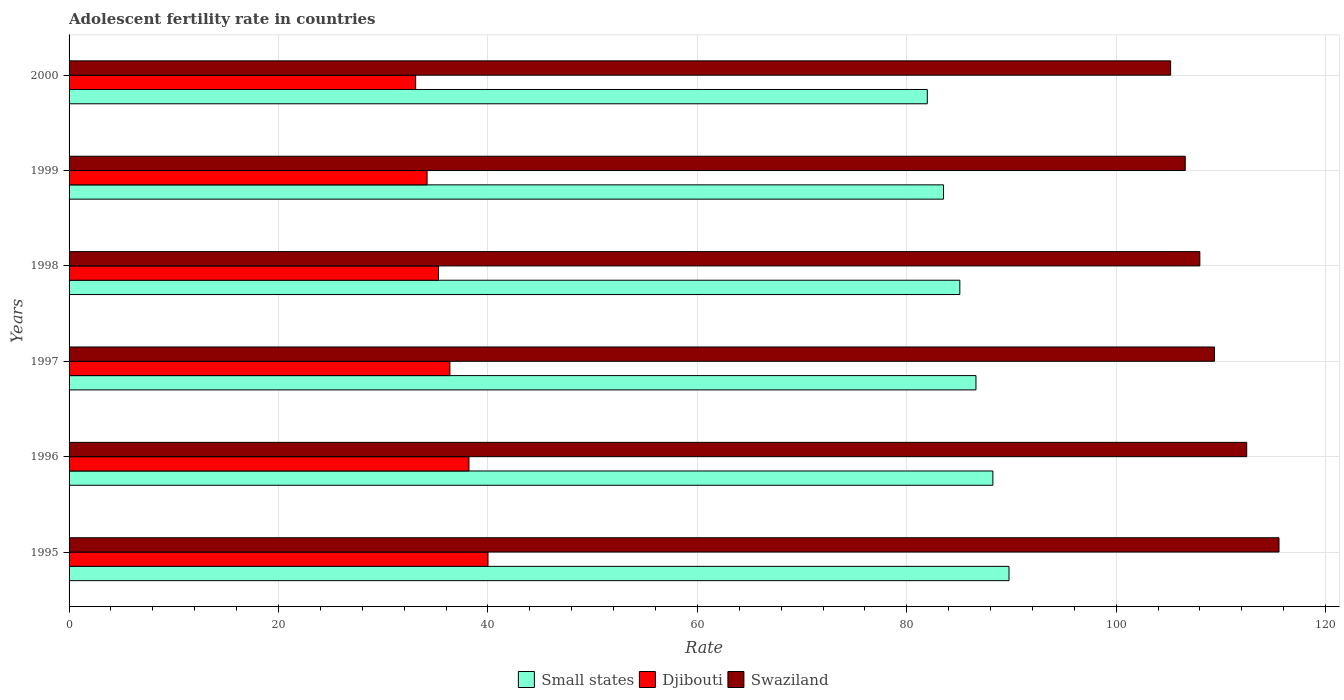Are the number of bars on each tick of the Y-axis equal?
Ensure brevity in your answer.  Yes. How many bars are there on the 3rd tick from the top?
Keep it short and to the point. 3. In how many cases, is the number of bars for a given year not equal to the number of legend labels?
Keep it short and to the point. 0. What is the adolescent fertility rate in Swaziland in 1998?
Your response must be concise. 107.99. Across all years, what is the maximum adolescent fertility rate in Small states?
Provide a short and direct response. 89.76. Across all years, what is the minimum adolescent fertility rate in Swaziland?
Provide a short and direct response. 105.2. In which year was the adolescent fertility rate in Djibouti maximum?
Your answer should be compact. 1995. What is the total adolescent fertility rate in Djibouti in the graph?
Give a very brief answer. 217.13. What is the difference between the adolescent fertility rate in Swaziland in 1997 and that in 1999?
Ensure brevity in your answer.  2.79. What is the difference between the adolescent fertility rate in Swaziland in 1998 and the adolescent fertility rate in Djibouti in 1997?
Provide a succinct answer. 71.62. What is the average adolescent fertility rate in Swaziland per year?
Provide a short and direct response. 109.53. In the year 2000, what is the difference between the adolescent fertility rate in Djibouti and adolescent fertility rate in Small states?
Keep it short and to the point. -48.86. What is the ratio of the adolescent fertility rate in Djibouti in 1998 to that in 1999?
Your answer should be very brief. 1.03. What is the difference between the highest and the second highest adolescent fertility rate in Swaziland?
Your answer should be very brief. 3.08. What is the difference between the highest and the lowest adolescent fertility rate in Swaziland?
Offer a terse response. 10.35. In how many years, is the adolescent fertility rate in Small states greater than the average adolescent fertility rate in Small states taken over all years?
Offer a very short reply. 3. Is the sum of the adolescent fertility rate in Djibouti in 1998 and 2000 greater than the maximum adolescent fertility rate in Small states across all years?
Offer a terse response. No. What does the 2nd bar from the top in 2000 represents?
Offer a terse response. Djibouti. What does the 3rd bar from the bottom in 1997 represents?
Offer a very short reply. Swaziland. Are all the bars in the graph horizontal?
Your answer should be very brief. Yes. How many years are there in the graph?
Offer a terse response. 6. What is the difference between two consecutive major ticks on the X-axis?
Your response must be concise. 20. Are the values on the major ticks of X-axis written in scientific E-notation?
Ensure brevity in your answer.  No. Does the graph contain any zero values?
Your answer should be very brief. No. What is the title of the graph?
Make the answer very short. Adolescent fertility rate in countries. What is the label or title of the X-axis?
Offer a terse response. Rate. What is the Rate of Small states in 1995?
Provide a short and direct response. 89.76. What is the Rate in Djibouti in 1995?
Your answer should be compact. 40.01. What is the Rate of Swaziland in 1995?
Your answer should be very brief. 115.55. What is the Rate of Small states in 1996?
Your answer should be very brief. 88.22. What is the Rate of Djibouti in 1996?
Your answer should be very brief. 38.19. What is the Rate of Swaziland in 1996?
Ensure brevity in your answer.  112.47. What is the Rate in Small states in 1997?
Your response must be concise. 86.61. What is the Rate in Djibouti in 1997?
Your answer should be compact. 36.37. What is the Rate of Swaziland in 1997?
Provide a short and direct response. 109.38. What is the Rate in Small states in 1998?
Make the answer very short. 85.07. What is the Rate in Djibouti in 1998?
Offer a very short reply. 35.28. What is the Rate of Swaziland in 1998?
Your answer should be very brief. 107.99. What is the Rate in Small states in 1999?
Make the answer very short. 83.51. What is the Rate of Djibouti in 1999?
Ensure brevity in your answer.  34.19. What is the Rate of Swaziland in 1999?
Your answer should be very brief. 106.59. What is the Rate of Small states in 2000?
Your answer should be very brief. 81.96. What is the Rate in Djibouti in 2000?
Ensure brevity in your answer.  33.1. What is the Rate in Swaziland in 2000?
Your answer should be compact. 105.2. Across all years, what is the maximum Rate of Small states?
Offer a terse response. 89.76. Across all years, what is the maximum Rate of Djibouti?
Give a very brief answer. 40.01. Across all years, what is the maximum Rate of Swaziland?
Your response must be concise. 115.55. Across all years, what is the minimum Rate in Small states?
Your response must be concise. 81.96. Across all years, what is the minimum Rate of Djibouti?
Provide a short and direct response. 33.1. Across all years, what is the minimum Rate of Swaziland?
Provide a succinct answer. 105.2. What is the total Rate in Small states in the graph?
Make the answer very short. 515.13. What is the total Rate of Djibouti in the graph?
Ensure brevity in your answer.  217.13. What is the total Rate of Swaziland in the graph?
Offer a terse response. 657.17. What is the difference between the Rate in Small states in 1995 and that in 1996?
Your answer should be very brief. 1.54. What is the difference between the Rate in Djibouti in 1995 and that in 1996?
Offer a very short reply. 1.82. What is the difference between the Rate of Swaziland in 1995 and that in 1996?
Offer a very short reply. 3.08. What is the difference between the Rate in Small states in 1995 and that in 1997?
Provide a short and direct response. 3.16. What is the difference between the Rate in Djibouti in 1995 and that in 1997?
Provide a short and direct response. 3.64. What is the difference between the Rate of Swaziland in 1995 and that in 1997?
Ensure brevity in your answer.  6.16. What is the difference between the Rate of Small states in 1995 and that in 1998?
Your response must be concise. 4.7. What is the difference between the Rate of Djibouti in 1995 and that in 1998?
Your response must be concise. 4.73. What is the difference between the Rate of Swaziland in 1995 and that in 1998?
Offer a very short reply. 7.56. What is the difference between the Rate of Small states in 1995 and that in 1999?
Provide a short and direct response. 6.25. What is the difference between the Rate of Djibouti in 1995 and that in 1999?
Keep it short and to the point. 5.82. What is the difference between the Rate of Swaziland in 1995 and that in 1999?
Keep it short and to the point. 8.95. What is the difference between the Rate of Small states in 1995 and that in 2000?
Offer a terse response. 7.8. What is the difference between the Rate in Djibouti in 1995 and that in 2000?
Ensure brevity in your answer.  6.91. What is the difference between the Rate of Swaziland in 1995 and that in 2000?
Provide a short and direct response. 10.35. What is the difference between the Rate in Small states in 1996 and that in 1997?
Ensure brevity in your answer.  1.61. What is the difference between the Rate in Djibouti in 1996 and that in 1997?
Offer a very short reply. 1.82. What is the difference between the Rate of Swaziland in 1996 and that in 1997?
Offer a very short reply. 3.08. What is the difference between the Rate of Small states in 1996 and that in 1998?
Your answer should be compact. 3.16. What is the difference between the Rate of Djibouti in 1996 and that in 1998?
Give a very brief answer. 2.91. What is the difference between the Rate in Swaziland in 1996 and that in 1998?
Your answer should be very brief. 4.48. What is the difference between the Rate of Small states in 1996 and that in 1999?
Ensure brevity in your answer.  4.71. What is the difference between the Rate in Djibouti in 1996 and that in 1999?
Offer a terse response. 4. What is the difference between the Rate of Swaziland in 1996 and that in 1999?
Offer a terse response. 5.87. What is the difference between the Rate of Small states in 1996 and that in 2000?
Keep it short and to the point. 6.26. What is the difference between the Rate in Djibouti in 1996 and that in 2000?
Offer a terse response. 5.09. What is the difference between the Rate of Swaziland in 1996 and that in 2000?
Make the answer very short. 7.27. What is the difference between the Rate in Small states in 1997 and that in 1998?
Your answer should be compact. 1.54. What is the difference between the Rate of Djibouti in 1997 and that in 1998?
Provide a succinct answer. 1.09. What is the difference between the Rate of Swaziland in 1997 and that in 1998?
Ensure brevity in your answer.  1.4. What is the difference between the Rate of Small states in 1997 and that in 1999?
Give a very brief answer. 3.1. What is the difference between the Rate in Djibouti in 1997 and that in 1999?
Your response must be concise. 2.18. What is the difference between the Rate of Swaziland in 1997 and that in 1999?
Offer a very short reply. 2.79. What is the difference between the Rate in Small states in 1997 and that in 2000?
Provide a short and direct response. 4.65. What is the difference between the Rate in Djibouti in 1997 and that in 2000?
Provide a short and direct response. 3.27. What is the difference between the Rate in Swaziland in 1997 and that in 2000?
Keep it short and to the point. 4.19. What is the difference between the Rate of Small states in 1998 and that in 1999?
Make the answer very short. 1.56. What is the difference between the Rate in Djibouti in 1998 and that in 1999?
Make the answer very short. 1.09. What is the difference between the Rate of Swaziland in 1998 and that in 1999?
Make the answer very short. 1.4. What is the difference between the Rate of Small states in 1998 and that in 2000?
Provide a succinct answer. 3.11. What is the difference between the Rate of Djibouti in 1998 and that in 2000?
Ensure brevity in your answer.  2.18. What is the difference between the Rate in Swaziland in 1998 and that in 2000?
Keep it short and to the point. 2.79. What is the difference between the Rate of Small states in 1999 and that in 2000?
Keep it short and to the point. 1.55. What is the difference between the Rate in Djibouti in 1999 and that in 2000?
Ensure brevity in your answer.  1.09. What is the difference between the Rate in Swaziland in 1999 and that in 2000?
Provide a succinct answer. 1.4. What is the difference between the Rate of Small states in 1995 and the Rate of Djibouti in 1996?
Provide a succinct answer. 51.58. What is the difference between the Rate of Small states in 1995 and the Rate of Swaziland in 1996?
Provide a succinct answer. -22.7. What is the difference between the Rate in Djibouti in 1995 and the Rate in Swaziland in 1996?
Offer a very short reply. -72.46. What is the difference between the Rate in Small states in 1995 and the Rate in Djibouti in 1997?
Your answer should be very brief. 53.39. What is the difference between the Rate in Small states in 1995 and the Rate in Swaziland in 1997?
Provide a short and direct response. -19.62. What is the difference between the Rate in Djibouti in 1995 and the Rate in Swaziland in 1997?
Your answer should be very brief. -69.38. What is the difference between the Rate in Small states in 1995 and the Rate in Djibouti in 1998?
Ensure brevity in your answer.  54.48. What is the difference between the Rate of Small states in 1995 and the Rate of Swaziland in 1998?
Give a very brief answer. -18.22. What is the difference between the Rate in Djibouti in 1995 and the Rate in Swaziland in 1998?
Your response must be concise. -67.98. What is the difference between the Rate of Small states in 1995 and the Rate of Djibouti in 1999?
Provide a succinct answer. 55.57. What is the difference between the Rate in Small states in 1995 and the Rate in Swaziland in 1999?
Ensure brevity in your answer.  -16.83. What is the difference between the Rate in Djibouti in 1995 and the Rate in Swaziland in 1999?
Your answer should be compact. -66.58. What is the difference between the Rate of Small states in 1995 and the Rate of Djibouti in 2000?
Offer a terse response. 56.66. What is the difference between the Rate in Small states in 1995 and the Rate in Swaziland in 2000?
Ensure brevity in your answer.  -15.43. What is the difference between the Rate of Djibouti in 1995 and the Rate of Swaziland in 2000?
Provide a short and direct response. -65.19. What is the difference between the Rate of Small states in 1996 and the Rate of Djibouti in 1997?
Provide a short and direct response. 51.85. What is the difference between the Rate of Small states in 1996 and the Rate of Swaziland in 1997?
Ensure brevity in your answer.  -21.16. What is the difference between the Rate in Djibouti in 1996 and the Rate in Swaziland in 1997?
Ensure brevity in your answer.  -71.19. What is the difference between the Rate in Small states in 1996 and the Rate in Djibouti in 1998?
Your response must be concise. 52.94. What is the difference between the Rate of Small states in 1996 and the Rate of Swaziland in 1998?
Keep it short and to the point. -19.77. What is the difference between the Rate of Djibouti in 1996 and the Rate of Swaziland in 1998?
Keep it short and to the point. -69.8. What is the difference between the Rate of Small states in 1996 and the Rate of Djibouti in 1999?
Provide a succinct answer. 54.03. What is the difference between the Rate in Small states in 1996 and the Rate in Swaziland in 1999?
Your answer should be compact. -18.37. What is the difference between the Rate in Djibouti in 1996 and the Rate in Swaziland in 1999?
Provide a succinct answer. -68.4. What is the difference between the Rate in Small states in 1996 and the Rate in Djibouti in 2000?
Give a very brief answer. 55.12. What is the difference between the Rate of Small states in 1996 and the Rate of Swaziland in 2000?
Offer a very short reply. -16.98. What is the difference between the Rate of Djibouti in 1996 and the Rate of Swaziland in 2000?
Give a very brief answer. -67.01. What is the difference between the Rate in Small states in 1997 and the Rate in Djibouti in 1998?
Provide a short and direct response. 51.33. What is the difference between the Rate of Small states in 1997 and the Rate of Swaziland in 1998?
Your response must be concise. -21.38. What is the difference between the Rate of Djibouti in 1997 and the Rate of Swaziland in 1998?
Offer a terse response. -71.62. What is the difference between the Rate of Small states in 1997 and the Rate of Djibouti in 1999?
Provide a succinct answer. 52.42. What is the difference between the Rate in Small states in 1997 and the Rate in Swaziland in 1999?
Offer a very short reply. -19.98. What is the difference between the Rate of Djibouti in 1997 and the Rate of Swaziland in 1999?
Make the answer very short. -70.22. What is the difference between the Rate in Small states in 1997 and the Rate in Djibouti in 2000?
Provide a short and direct response. 53.51. What is the difference between the Rate in Small states in 1997 and the Rate in Swaziland in 2000?
Your answer should be compact. -18.59. What is the difference between the Rate of Djibouti in 1997 and the Rate of Swaziland in 2000?
Offer a very short reply. -68.83. What is the difference between the Rate of Small states in 1998 and the Rate of Djibouti in 1999?
Keep it short and to the point. 50.88. What is the difference between the Rate in Small states in 1998 and the Rate in Swaziland in 1999?
Offer a terse response. -21.53. What is the difference between the Rate in Djibouti in 1998 and the Rate in Swaziland in 1999?
Ensure brevity in your answer.  -71.31. What is the difference between the Rate in Small states in 1998 and the Rate in Djibouti in 2000?
Provide a succinct answer. 51.97. What is the difference between the Rate in Small states in 1998 and the Rate in Swaziland in 2000?
Your answer should be compact. -20.13. What is the difference between the Rate of Djibouti in 1998 and the Rate of Swaziland in 2000?
Provide a succinct answer. -69.92. What is the difference between the Rate of Small states in 1999 and the Rate of Djibouti in 2000?
Offer a terse response. 50.41. What is the difference between the Rate of Small states in 1999 and the Rate of Swaziland in 2000?
Keep it short and to the point. -21.69. What is the difference between the Rate in Djibouti in 1999 and the Rate in Swaziland in 2000?
Provide a succinct answer. -71.01. What is the average Rate of Small states per year?
Provide a succinct answer. 85.86. What is the average Rate in Djibouti per year?
Ensure brevity in your answer.  36.19. What is the average Rate in Swaziland per year?
Offer a terse response. 109.53. In the year 1995, what is the difference between the Rate of Small states and Rate of Djibouti?
Your answer should be compact. 49.76. In the year 1995, what is the difference between the Rate of Small states and Rate of Swaziland?
Give a very brief answer. -25.78. In the year 1995, what is the difference between the Rate in Djibouti and Rate in Swaziland?
Provide a succinct answer. -75.54. In the year 1996, what is the difference between the Rate of Small states and Rate of Djibouti?
Your answer should be very brief. 50.03. In the year 1996, what is the difference between the Rate of Small states and Rate of Swaziland?
Your answer should be very brief. -24.24. In the year 1996, what is the difference between the Rate in Djibouti and Rate in Swaziland?
Make the answer very short. -74.28. In the year 1997, what is the difference between the Rate in Small states and Rate in Djibouti?
Offer a terse response. 50.24. In the year 1997, what is the difference between the Rate in Small states and Rate in Swaziland?
Give a very brief answer. -22.78. In the year 1997, what is the difference between the Rate in Djibouti and Rate in Swaziland?
Your answer should be very brief. -73.01. In the year 1998, what is the difference between the Rate in Small states and Rate in Djibouti?
Make the answer very short. 49.79. In the year 1998, what is the difference between the Rate of Small states and Rate of Swaziland?
Keep it short and to the point. -22.92. In the year 1998, what is the difference between the Rate of Djibouti and Rate of Swaziland?
Provide a succinct answer. -72.71. In the year 1999, what is the difference between the Rate of Small states and Rate of Djibouti?
Keep it short and to the point. 49.32. In the year 1999, what is the difference between the Rate in Small states and Rate in Swaziland?
Keep it short and to the point. -23.08. In the year 1999, what is the difference between the Rate of Djibouti and Rate of Swaziland?
Your answer should be compact. -72.4. In the year 2000, what is the difference between the Rate in Small states and Rate in Djibouti?
Offer a very short reply. 48.86. In the year 2000, what is the difference between the Rate of Small states and Rate of Swaziland?
Provide a short and direct response. -23.24. In the year 2000, what is the difference between the Rate in Djibouti and Rate in Swaziland?
Your answer should be compact. -72.1. What is the ratio of the Rate of Small states in 1995 to that in 1996?
Provide a succinct answer. 1.02. What is the ratio of the Rate in Djibouti in 1995 to that in 1996?
Make the answer very short. 1.05. What is the ratio of the Rate of Swaziland in 1995 to that in 1996?
Offer a terse response. 1.03. What is the ratio of the Rate in Small states in 1995 to that in 1997?
Your answer should be very brief. 1.04. What is the ratio of the Rate of Djibouti in 1995 to that in 1997?
Give a very brief answer. 1.1. What is the ratio of the Rate of Swaziland in 1995 to that in 1997?
Your answer should be compact. 1.06. What is the ratio of the Rate in Small states in 1995 to that in 1998?
Make the answer very short. 1.06. What is the ratio of the Rate of Djibouti in 1995 to that in 1998?
Your response must be concise. 1.13. What is the ratio of the Rate of Swaziland in 1995 to that in 1998?
Make the answer very short. 1.07. What is the ratio of the Rate of Small states in 1995 to that in 1999?
Your response must be concise. 1.07. What is the ratio of the Rate of Djibouti in 1995 to that in 1999?
Ensure brevity in your answer.  1.17. What is the ratio of the Rate of Swaziland in 1995 to that in 1999?
Provide a short and direct response. 1.08. What is the ratio of the Rate of Small states in 1995 to that in 2000?
Offer a very short reply. 1.1. What is the ratio of the Rate in Djibouti in 1995 to that in 2000?
Give a very brief answer. 1.21. What is the ratio of the Rate in Swaziland in 1995 to that in 2000?
Provide a succinct answer. 1.1. What is the ratio of the Rate of Small states in 1996 to that in 1997?
Your response must be concise. 1.02. What is the ratio of the Rate in Djibouti in 1996 to that in 1997?
Offer a terse response. 1.05. What is the ratio of the Rate in Swaziland in 1996 to that in 1997?
Offer a very short reply. 1.03. What is the ratio of the Rate in Small states in 1996 to that in 1998?
Keep it short and to the point. 1.04. What is the ratio of the Rate of Djibouti in 1996 to that in 1998?
Your answer should be compact. 1.08. What is the ratio of the Rate of Swaziland in 1996 to that in 1998?
Offer a terse response. 1.04. What is the ratio of the Rate of Small states in 1996 to that in 1999?
Your answer should be very brief. 1.06. What is the ratio of the Rate in Djibouti in 1996 to that in 1999?
Your answer should be compact. 1.12. What is the ratio of the Rate of Swaziland in 1996 to that in 1999?
Provide a short and direct response. 1.06. What is the ratio of the Rate of Small states in 1996 to that in 2000?
Keep it short and to the point. 1.08. What is the ratio of the Rate of Djibouti in 1996 to that in 2000?
Keep it short and to the point. 1.15. What is the ratio of the Rate of Swaziland in 1996 to that in 2000?
Your response must be concise. 1.07. What is the ratio of the Rate in Small states in 1997 to that in 1998?
Offer a terse response. 1.02. What is the ratio of the Rate in Djibouti in 1997 to that in 1998?
Keep it short and to the point. 1.03. What is the ratio of the Rate in Swaziland in 1997 to that in 1998?
Give a very brief answer. 1.01. What is the ratio of the Rate of Small states in 1997 to that in 1999?
Your answer should be very brief. 1.04. What is the ratio of the Rate in Djibouti in 1997 to that in 1999?
Provide a short and direct response. 1.06. What is the ratio of the Rate of Swaziland in 1997 to that in 1999?
Give a very brief answer. 1.03. What is the ratio of the Rate in Small states in 1997 to that in 2000?
Offer a terse response. 1.06. What is the ratio of the Rate in Djibouti in 1997 to that in 2000?
Provide a short and direct response. 1.1. What is the ratio of the Rate in Swaziland in 1997 to that in 2000?
Provide a short and direct response. 1.04. What is the ratio of the Rate of Small states in 1998 to that in 1999?
Keep it short and to the point. 1.02. What is the ratio of the Rate in Djibouti in 1998 to that in 1999?
Keep it short and to the point. 1.03. What is the ratio of the Rate of Swaziland in 1998 to that in 1999?
Offer a very short reply. 1.01. What is the ratio of the Rate of Small states in 1998 to that in 2000?
Provide a short and direct response. 1.04. What is the ratio of the Rate of Djibouti in 1998 to that in 2000?
Provide a succinct answer. 1.07. What is the ratio of the Rate of Swaziland in 1998 to that in 2000?
Your answer should be compact. 1.03. What is the ratio of the Rate in Small states in 1999 to that in 2000?
Give a very brief answer. 1.02. What is the ratio of the Rate in Djibouti in 1999 to that in 2000?
Make the answer very short. 1.03. What is the ratio of the Rate in Swaziland in 1999 to that in 2000?
Your answer should be compact. 1.01. What is the difference between the highest and the second highest Rate of Small states?
Keep it short and to the point. 1.54. What is the difference between the highest and the second highest Rate in Djibouti?
Offer a very short reply. 1.82. What is the difference between the highest and the second highest Rate of Swaziland?
Offer a terse response. 3.08. What is the difference between the highest and the lowest Rate of Small states?
Offer a very short reply. 7.8. What is the difference between the highest and the lowest Rate of Djibouti?
Your answer should be compact. 6.91. What is the difference between the highest and the lowest Rate of Swaziland?
Make the answer very short. 10.35. 